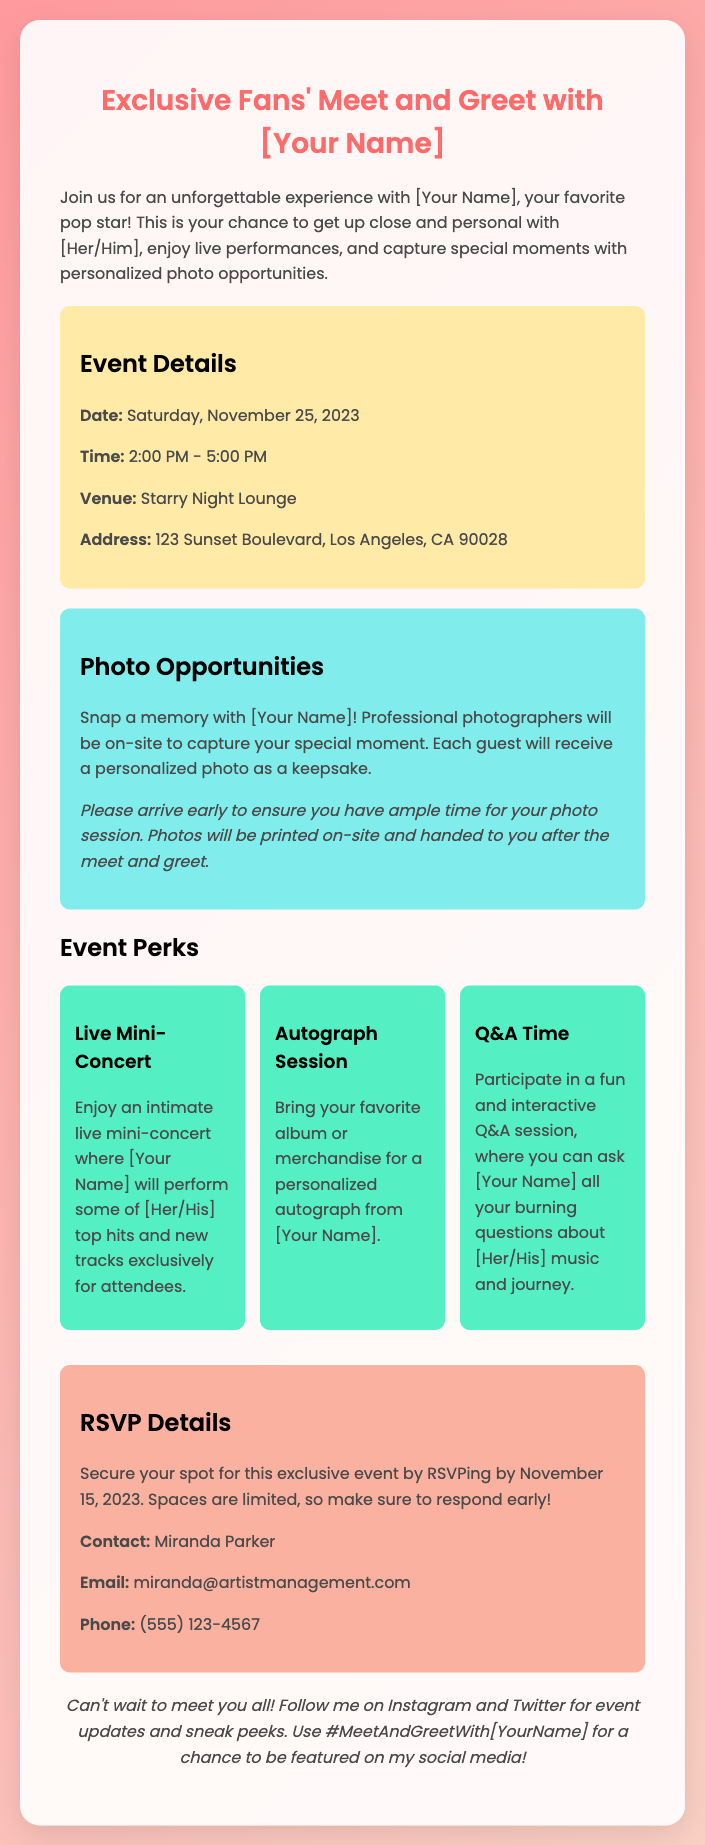What is the date of the event? The date of the event is mentioned in the document, which is Saturday, November 25, 2023.
Answer: Saturday, November 25, 2023 What time does the event start? The start time of the event is included in the event details section, which is at 2:00 PM.
Answer: 2:00 PM Where is the venue located? The venue location is provided in the event details, specifically stating "Starry Night Lounge" with an address.
Answer: Starry Night Lounge Who should attendees contact for RSVP? The document specifies that attendees should contact Miranda Parker for RSVP details.
Answer: Miranda Parker What is one of the perks of attending the event? The perks section highlights various benefits, one being a live mini-concert where the artist performs.
Answer: Live Mini-Concert How can fans RSVP for the event? The RSVP details instruct fans to respond by a specific date which is listed in the document as November 15, 2023.
Answer: November 15, 2023 What keepsake will each guest receive? The document mentions that guests will receive a personalized photo as a keepsake after the photo opportunity.
Answer: Personalized photo How long will the event last? The duration of the event is given in the document, indicating it lasts from 2:00 PM to 5:00 PM, which is a 3-hour duration.
Answer: 3 hours What social media hashtag can attendees use? The document provides a specific hashtag for attendees to use for social media posts, which is mentioned at the end of the RSVP card.
Answer: #MeetAndGreetWith[YourName] 